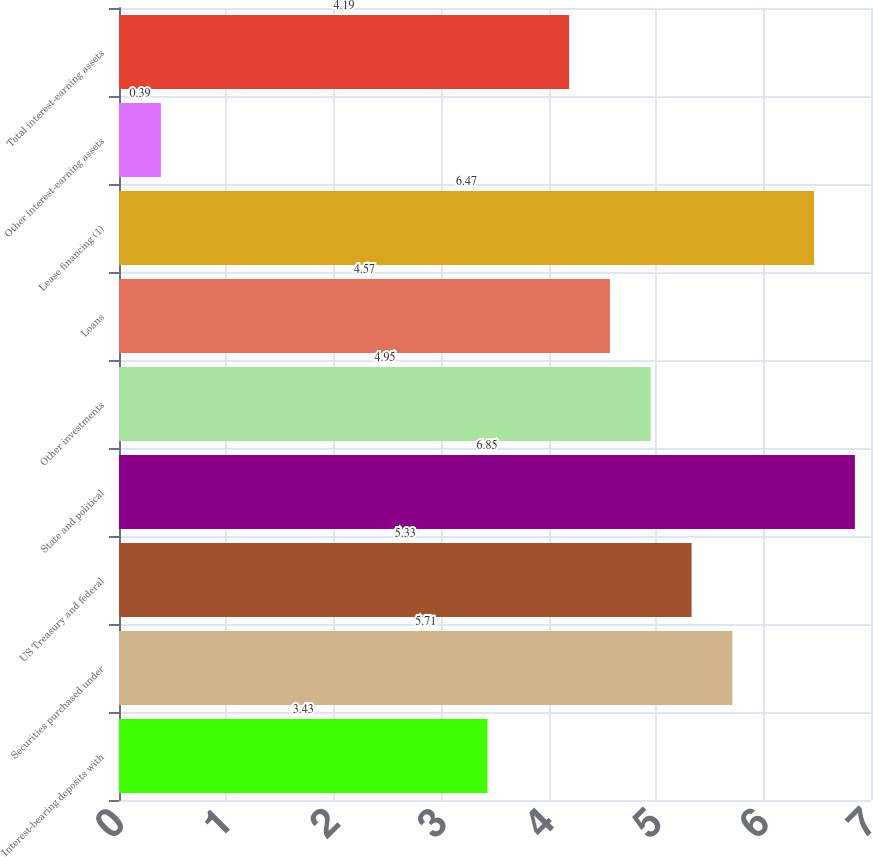Convert chart. <chart><loc_0><loc_0><loc_500><loc_500><bar_chart><fcel>Interest-bearing deposits with<fcel>Securities purchased under<fcel>US Treasury and federal<fcel>State and political<fcel>Other investments<fcel>Loans<fcel>Lease financing (1)<fcel>Other interest-earning assets<fcel>Total interest-earning assets<nl><fcel>3.43<fcel>5.71<fcel>5.33<fcel>6.85<fcel>4.95<fcel>4.57<fcel>6.47<fcel>0.39<fcel>4.19<nl></chart> 